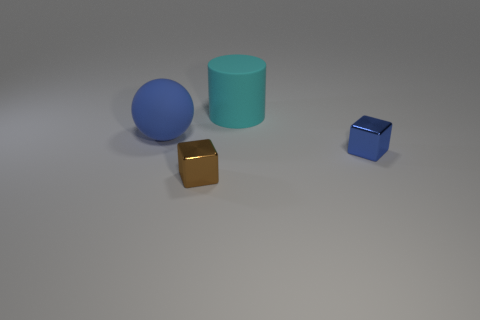How many other objects are there of the same color as the matte sphere?
Your answer should be compact. 1. There is a thing that is the same color as the rubber sphere; what is it made of?
Your response must be concise. Metal. How many blue things are there?
Provide a succinct answer. 2. The thing that is behind the big blue matte object is what color?
Your response must be concise. Cyan. The brown metallic object has what size?
Your response must be concise. Small. There is a matte sphere; is its color the same as the small object behind the brown thing?
Ensure brevity in your answer.  Yes. What is the color of the metal thing in front of the blue thing that is in front of the big blue matte ball?
Give a very brief answer. Brown. Is the shape of the small shiny thing that is in front of the blue block the same as  the small blue object?
Offer a terse response. Yes. How many objects are both in front of the cyan cylinder and behind the brown thing?
Offer a very short reply. 2. What color is the tiny shiny block that is to the right of the cyan thing that is behind the shiny thing on the right side of the large cyan rubber cylinder?
Offer a very short reply. Blue. 